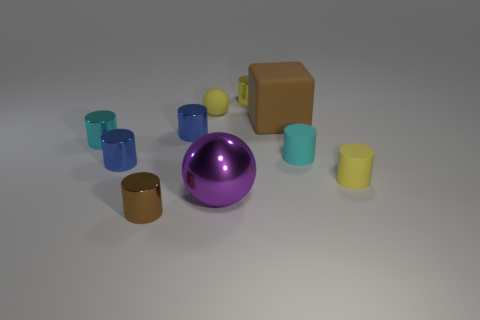Subtract all yellow cylinders. How many cylinders are left? 5 Subtract all rubber cylinders. How many cylinders are left? 5 Subtract all blue cylinders. Subtract all cyan spheres. How many cylinders are left? 5 Subtract all cubes. How many objects are left? 9 Subtract 1 cyan cylinders. How many objects are left? 9 Subtract all small brown shiny cylinders. Subtract all blue metal cylinders. How many objects are left? 7 Add 4 tiny brown objects. How many tiny brown objects are left? 5 Add 3 blue objects. How many blue objects exist? 5 